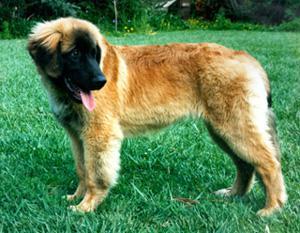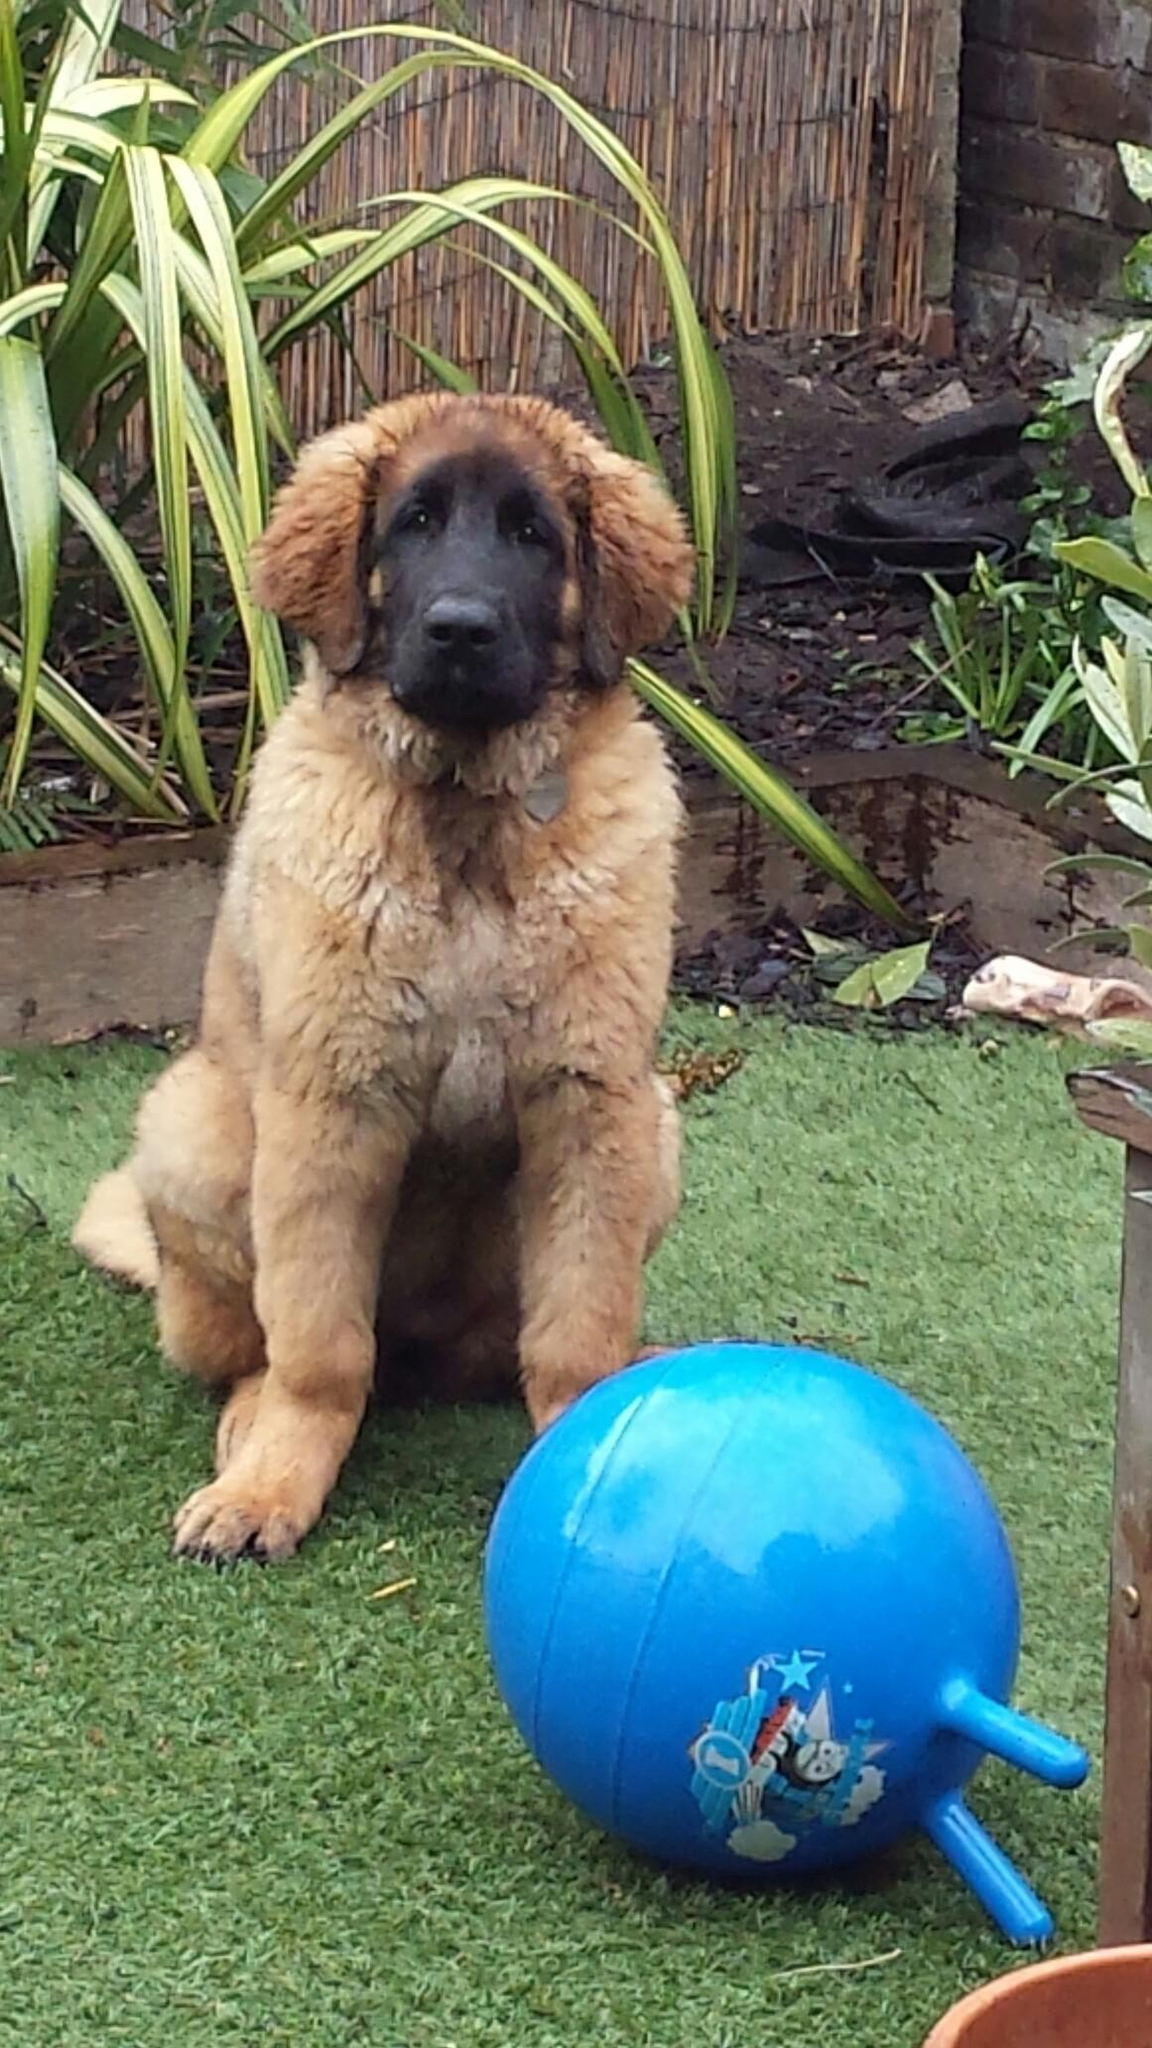The first image is the image on the left, the second image is the image on the right. For the images displayed, is the sentence "There are three dogs in the pair of images." factually correct? Answer yes or no. No. The first image is the image on the left, the second image is the image on the right. For the images shown, is this caption "A blue plastic plaything of some type is on the grass in one of the images featuring a big brownish-orange dog." true? Answer yes or no. Yes. 